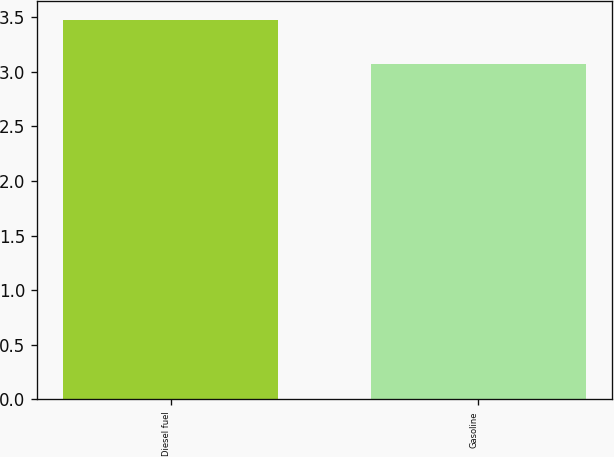Convert chart to OTSL. <chart><loc_0><loc_0><loc_500><loc_500><bar_chart><fcel>Diesel fuel<fcel>Gasoline<nl><fcel>3.47<fcel>3.07<nl></chart> 